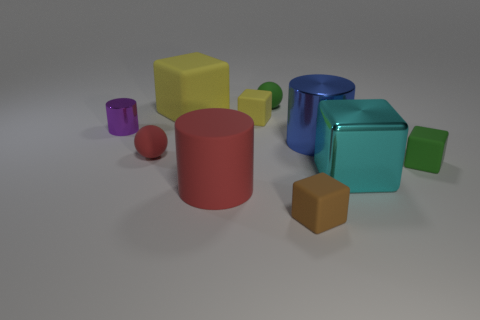Subtract all rubber cubes. How many cubes are left? 1 Subtract all gray cylinders. How many yellow cubes are left? 2 Subtract 2 blocks. How many blocks are left? 3 Subtract all yellow cubes. How many cubes are left? 3 Subtract all blue blocks. Subtract all brown cylinders. How many blocks are left? 5 Subtract all cylinders. How many objects are left? 7 Add 4 tiny blocks. How many tiny blocks exist? 7 Subtract 0 yellow cylinders. How many objects are left? 10 Subtract all yellow objects. Subtract all big yellow rubber cubes. How many objects are left? 7 Add 6 brown matte blocks. How many brown matte blocks are left? 7 